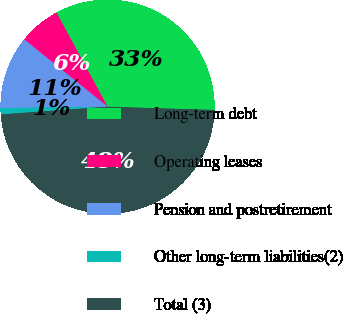<chart> <loc_0><loc_0><loc_500><loc_500><pie_chart><fcel>Long-term debt<fcel>Operating leases<fcel>Pension and postretirement<fcel>Other long-term liabilities(2)<fcel>Total (3)<nl><fcel>33.4%<fcel>6.27%<fcel>11.01%<fcel>0.95%<fcel>48.37%<nl></chart> 